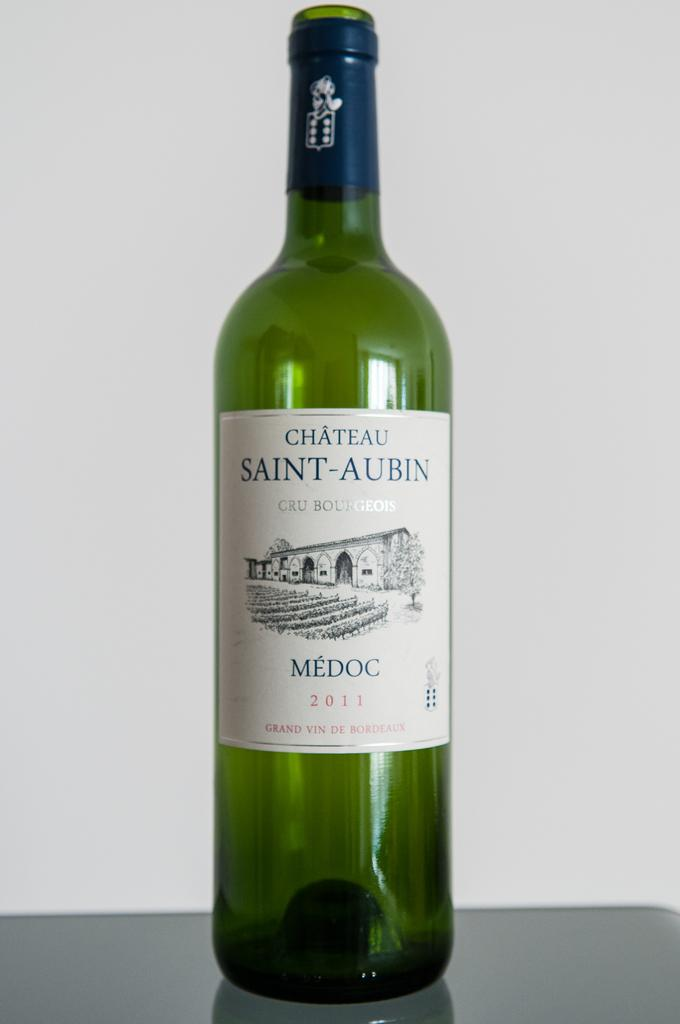What is the color of the bottle in the image? The bottle in the image is green. What else can be observed about the bottle? The bottle has a label. Where is the crow sitting on the throne in the image? There is no crow or throne present in the image; it only features a green color bottle with a label. 